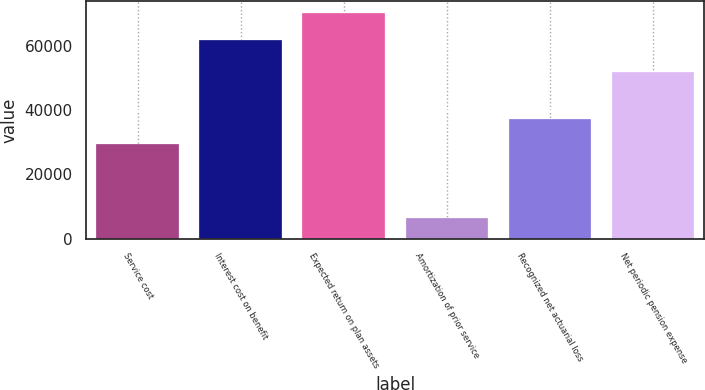Convert chart to OTSL. <chart><loc_0><loc_0><loc_500><loc_500><bar_chart><fcel>Service cost<fcel>Interest cost on benefit<fcel>Expected return on plan assets<fcel>Amortization of prior service<fcel>Recognized net actuarial loss<fcel>Net periodic pension expense<nl><fcel>29549<fcel>62037<fcel>70511<fcel>6559<fcel>37386<fcel>51902<nl></chart> 